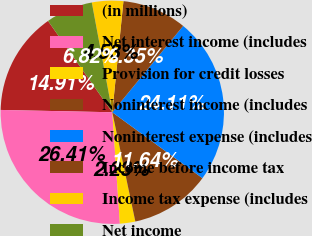<chart> <loc_0><loc_0><loc_500><loc_500><pie_chart><fcel>(in millions)<fcel>Net interest income (includes<fcel>Provision for credit losses<fcel>Noninterest income (includes<fcel>Noninterest expense (includes<fcel>Income before income tax<fcel>Income tax expense (includes<fcel>Net income<nl><fcel>14.91%<fcel>26.41%<fcel>2.23%<fcel>11.64%<fcel>24.11%<fcel>9.35%<fcel>4.53%<fcel>6.82%<nl></chart> 